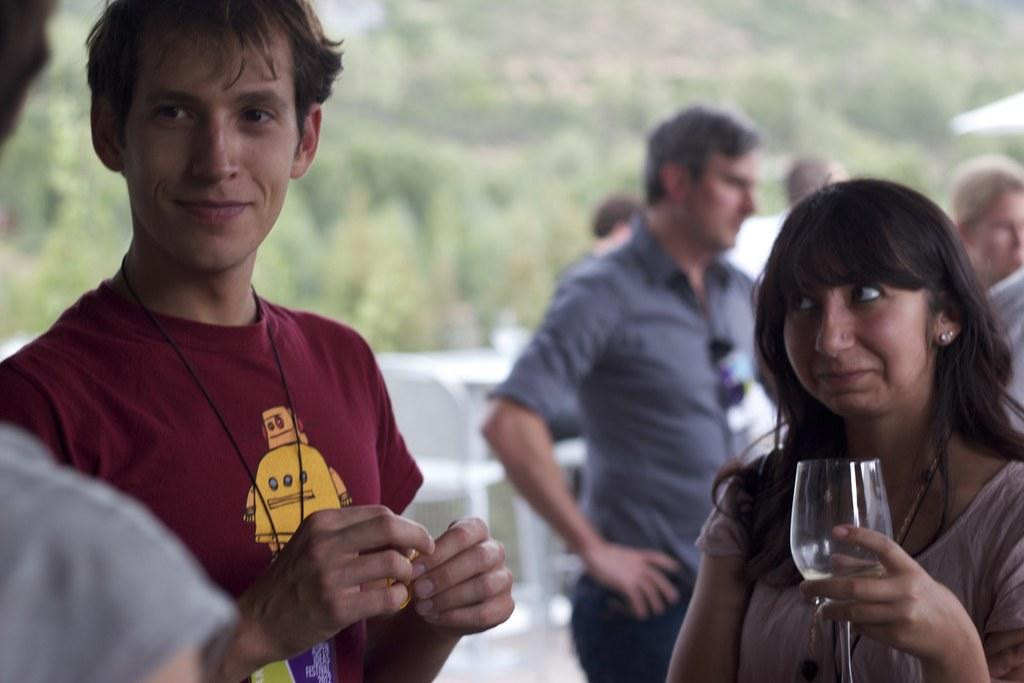Who or what can be seen in the image? There are people in the image. What are some of the people doing in the image? Some of the people are holding objects. What can be seen in the distance behind the people? There are trees in the background of the image. What type of coil is being used in the fight depicted in the image? There is no fight or coil present in the image; it features people and trees in the background. 